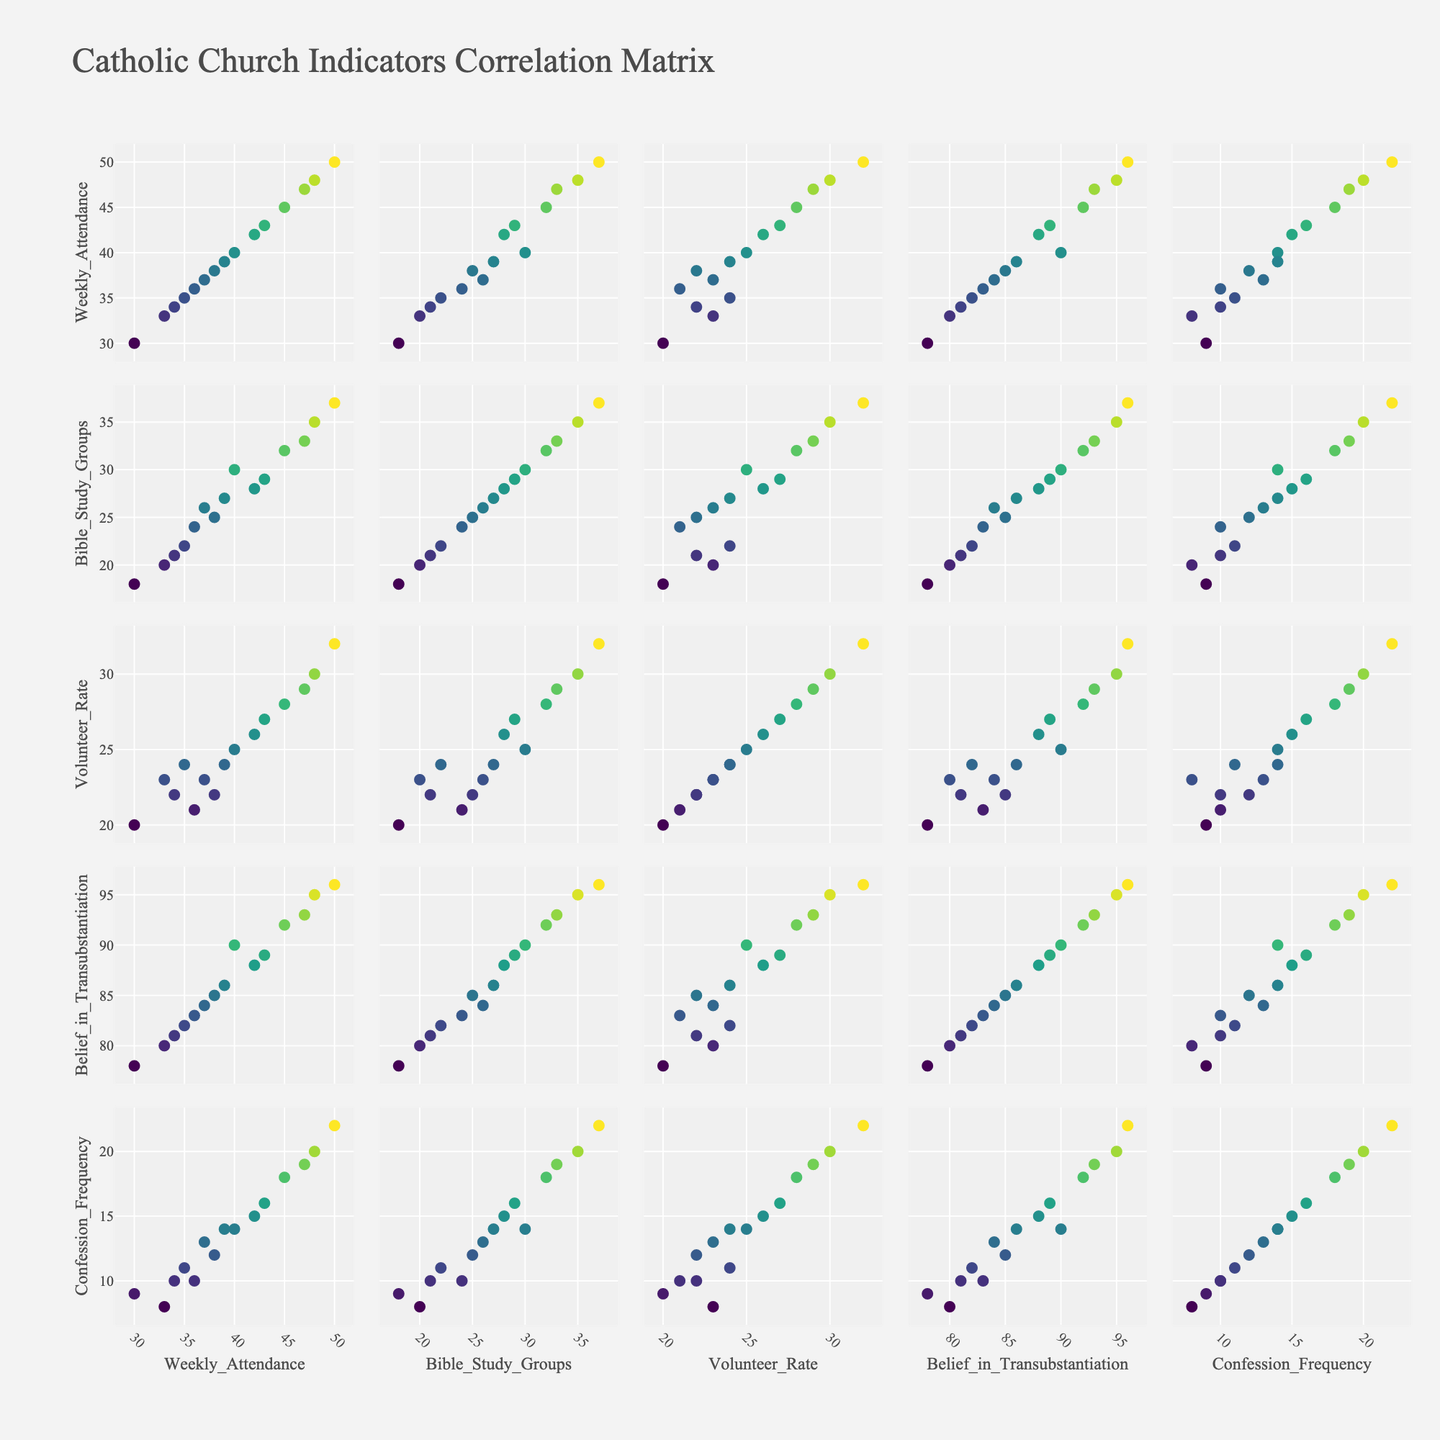What is the relationship between Weekly Attendance and Volunteer Rate? Examine the scatterplot corresponding to Weekly Attendance and Volunteer Rate. Identify if there is a visible trend or correlation between the dots representing dioceses in the figure.
Answer: Positive correlation Which diocese has the highest belief in Transubstantiation? Look for the scatterplot involving Belief in Transubstantiation and identify the highest y-axis value, then refer to the tooltip or color legend to find the corresponding diocese.
Answer: Manila Is there a pattern between Weekly Attendance and Confession Frequency? Check the scatterplot relating Weekly Attendance and Confession Frequency. Observe whether the data points tend to rise together (positive correlation), fall together (negative correlation), or show no clear pattern.
Answer: Positive correlation How does Bible Study Groups relate to Volunteer Rate? Look at the scatterplot comparing Bible Study Groups and Volunteer Rate. Determine if there’s a visible relationship where increases in Bible Study Groups correlate with Volunteer Rates.
Answer: Positive correlation Which two indicators show the strongest correlation? By inspecting all the scatterplots, check for pairs with the most consistent trend or pattern, indicating the strongest correlation. Analyze the density and direction of the data points.
Answer: Weekly Attendance and Belief in Transubstantiation What is the relationship between Bible Study Groups and Confession Frequency? Locate the scatterplot corresponding to Bible Study Groups and Confession Frequency, and observe the trend of data points to see if they are correlated.
Answer: Positive correlation Which diocese has the lowest Weekly Attendance, and how does it perform in terms of Belief in Transubstantiation? Find the scatterplot involving Weekly Attendance and identify the lowest point along the y-axis, note the diocese, and check its corresponding Belief in Transubstantiation value.
Answer: Paris; 78 Are there any dioceses that stand out for having high Weekly Attendance but low Volunteer Rates? Scan the scatterplots relating Weekly Attendance and Volunteer Rate. Identify any outlier data points where Weekly Attendance is significantly high, but Volunteer Rate is low.
Answer: No significant outliers Which indicators seem to have no clear correlation with Confession Frequency? Review all scatterplots involving Confession Frequency. Identify the plots where data points do not show a clear trend, clustering in no particular pattern.
Answer: No clear correlation with Volunteer Rate What can you infer about dioceses with high Weekly Attendance in terms of Bible Study Groups and Belief in Transubstantiation? Inspect scatterplots of Weekly Attendance with Bible Study Groups and Belief in Transubstantiation. Identify patterns or trends indicating whether dioceses with high Weekly Attendance also have high values in the other two indicators.
Answer: Generally high in both 